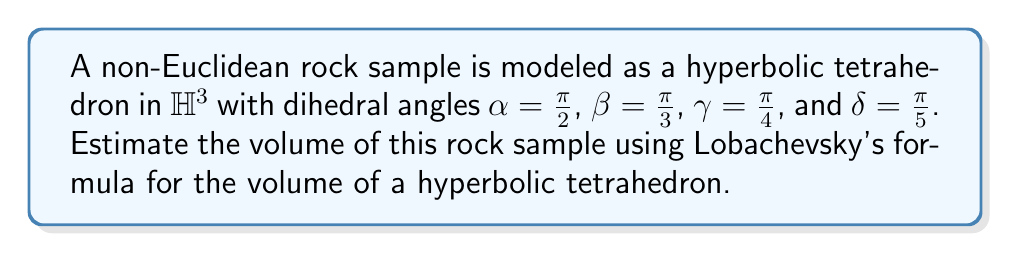Show me your answer to this math problem. 1) Lobachevsky's formula for the volume of a hyperbolic tetrahedron is:

   $$V = \frac{1}{4}(\Lambda(\alpha) + \Lambda(\beta) + \Lambda(\gamma) + \Lambda(\delta) - \pi)$$

   where $\Lambda(x)$ is Lobachevsky's function.

2) Lobachevsky's function is defined as:

   $$\Lambda(x) = -\int_0^x \ln|2\sin(t)| dt$$

3) We need to calculate $\Lambda(\frac{\pi}{2})$, $\Lambda(\frac{\pi}{3})$, $\Lambda(\frac{\pi}{4})$, and $\Lambda(\frac{\pi}{5})$.

4) These values can be approximated numerically:

   $\Lambda(\frac{\pi}{2}) \approx 0.9159655942$
   $\Lambda(\frac{\pi}{3}) \approx 1.0149416064$
   $\Lambda(\frac{\pi}{4}) \approx 0.9159655942$
   $\Lambda(\frac{\pi}{5}) \approx 0.7619274760$

5) Substituting these values into Lobachevsky's formula:

   $$V \approx \frac{1}{4}(0.9159655942 + 1.0149416064 + 0.9159655942 + 0.7619274760 - \pi)$$

6) Simplifying:

   $$V \approx \frac{1}{4}(3.6088002708 - \pi) \approx 0.0789577959$$

Therefore, the estimated volume of the rock sample is approximately 0.0789577959 cubic units in hyperbolic space.
Answer: $0.0789577959$ cubic units 